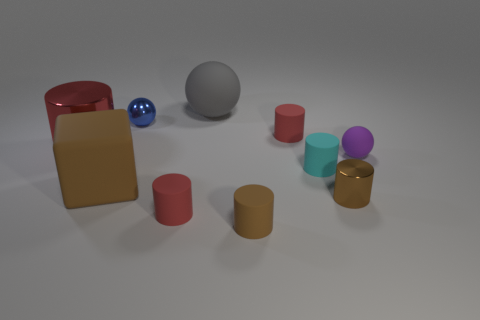What is the material of the object that is both right of the gray rubber ball and behind the purple matte sphere? The material of the object located to the right of the gray rubber ball and behind the purple matte sphere is rubber, similar to the gray ball. It appears to have a texture and sheen that is characteristic of rubber items. 